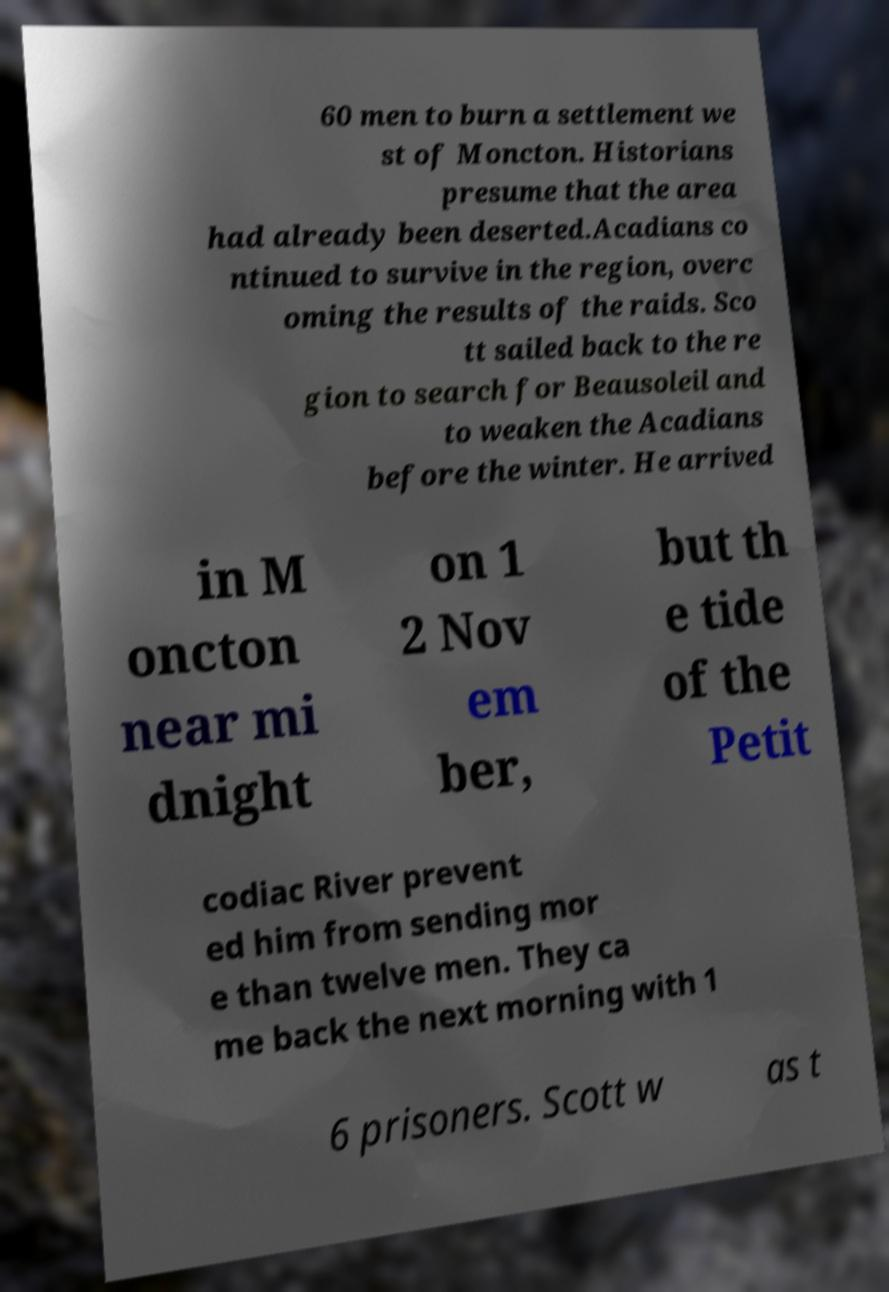Please read and relay the text visible in this image. What does it say? 60 men to burn a settlement we st of Moncton. Historians presume that the area had already been deserted.Acadians co ntinued to survive in the region, overc oming the results of the raids. Sco tt sailed back to the re gion to search for Beausoleil and to weaken the Acadians before the winter. He arrived in M oncton near mi dnight on 1 2 Nov em ber, but th e tide of the Petit codiac River prevent ed him from sending mor e than twelve men. They ca me back the next morning with 1 6 prisoners. Scott w as t 